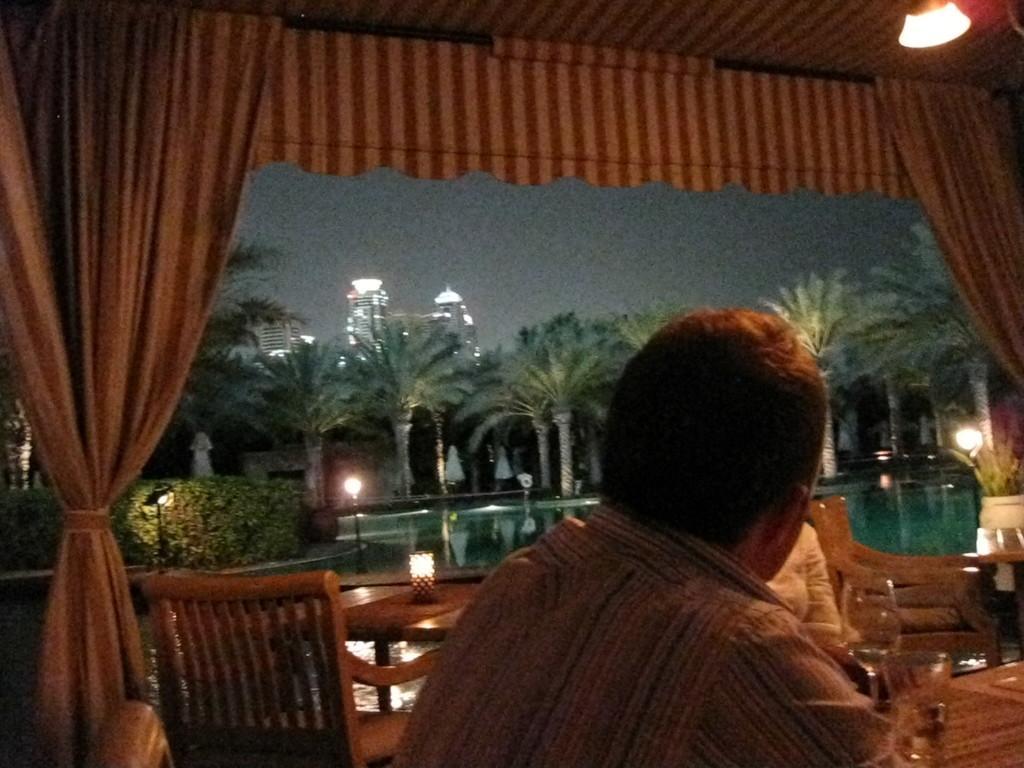In one or two sentences, can you explain what this image depicts? In this image I can see two persons are sitting on the chairs and glasses. In the background I can see curtains, plants, trees, buildings, light poles, water and the sky. This image is taken may be during night. 